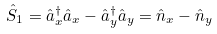<formula> <loc_0><loc_0><loc_500><loc_500>\hat { S } _ { 1 } = \hat { a } ^ { \dagger } _ { x } \hat { a } _ { x } - \hat { a } ^ { \dagger } _ { y } \hat { a } _ { y } = \hat { n } _ { x } - \hat { n } _ { y }</formula> 